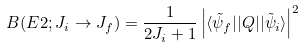Convert formula to latex. <formula><loc_0><loc_0><loc_500><loc_500>B ( E 2 ; J _ { i } \rightarrow J _ { f } ) = \frac { 1 } { 2 J _ { i } + 1 } \left | \langle \tilde { \psi } _ { f } | | Q | | \tilde { \psi } _ { i } \rangle \right | ^ { 2 }</formula> 